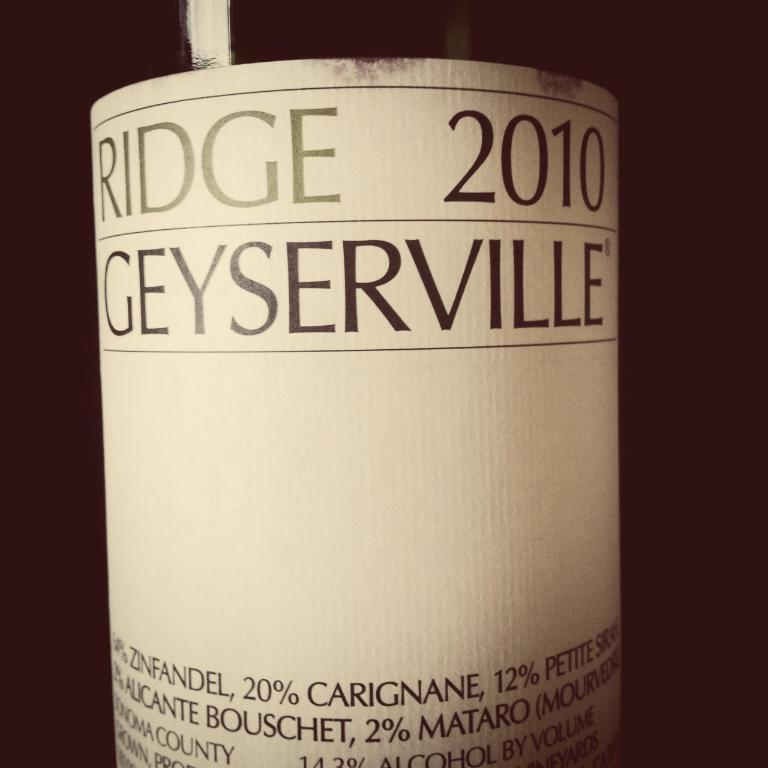What percentage of this is carignane?
Your answer should be compact. 20. 